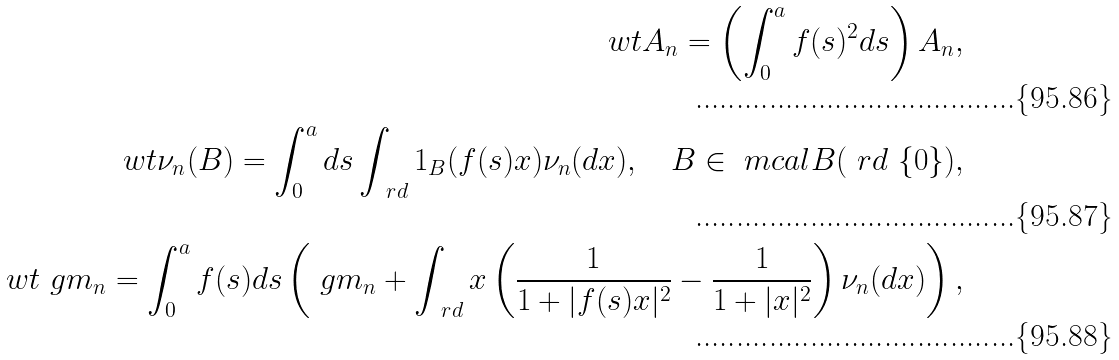<formula> <loc_0><loc_0><loc_500><loc_500>\ w t A _ { n } = \left ( \int _ { 0 } ^ { a } f ( s ) ^ { 2 } d s \right ) A _ { n } , \\ \ w t \nu _ { n } ( B ) = \int _ { 0 } ^ { a } d s \int _ { \ r d } 1 _ { B } ( f ( s ) x ) \nu _ { n } ( d x ) , \quad B \in \ m c a l B ( \ r d \ \{ 0 \} ) , \\ \ w t \ g m _ { n } = \int _ { 0 } ^ { a } f ( s ) d s \left ( \ g m _ { n } + \int _ { \ r d } x \left ( \frac { 1 } { 1 + | f ( s ) x | ^ { 2 } } - \frac { 1 } { 1 + | x | ^ { 2 } } \right ) \nu _ { n } ( d x ) \right ) ,</formula> 